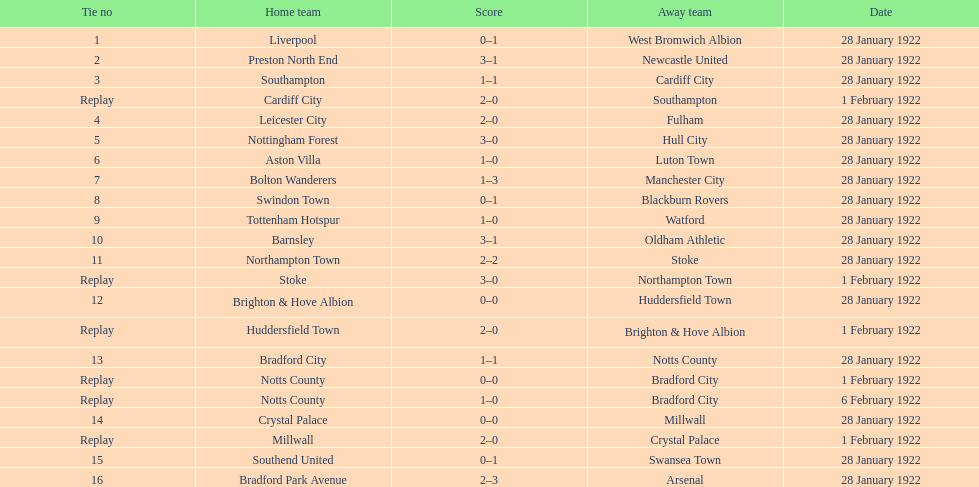Who is the first home team listed as having a score of 3-1? Preston North End. 